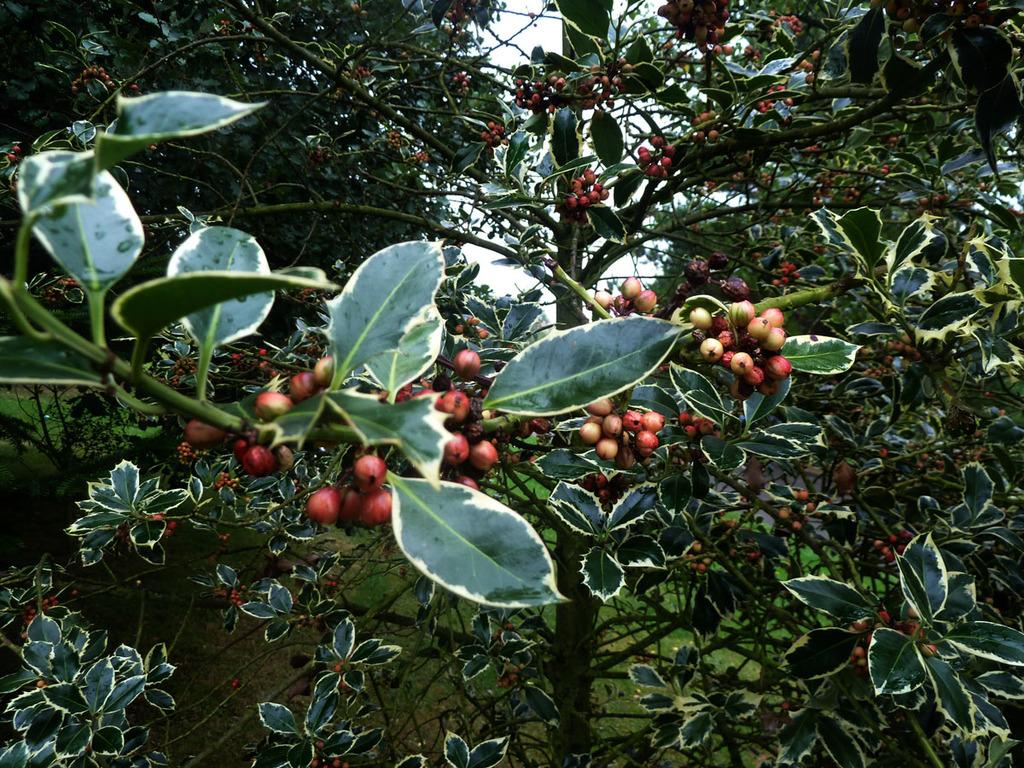What type of plants are visible in the front of the image? There are plants with fruits on them in the front of the image. What can be seen in the background of the image? There are plants in the background of the image. What type of brass instrument is being played in the image? There is no brass instrument present in the image; it features plants with fruits and plants in the background. 